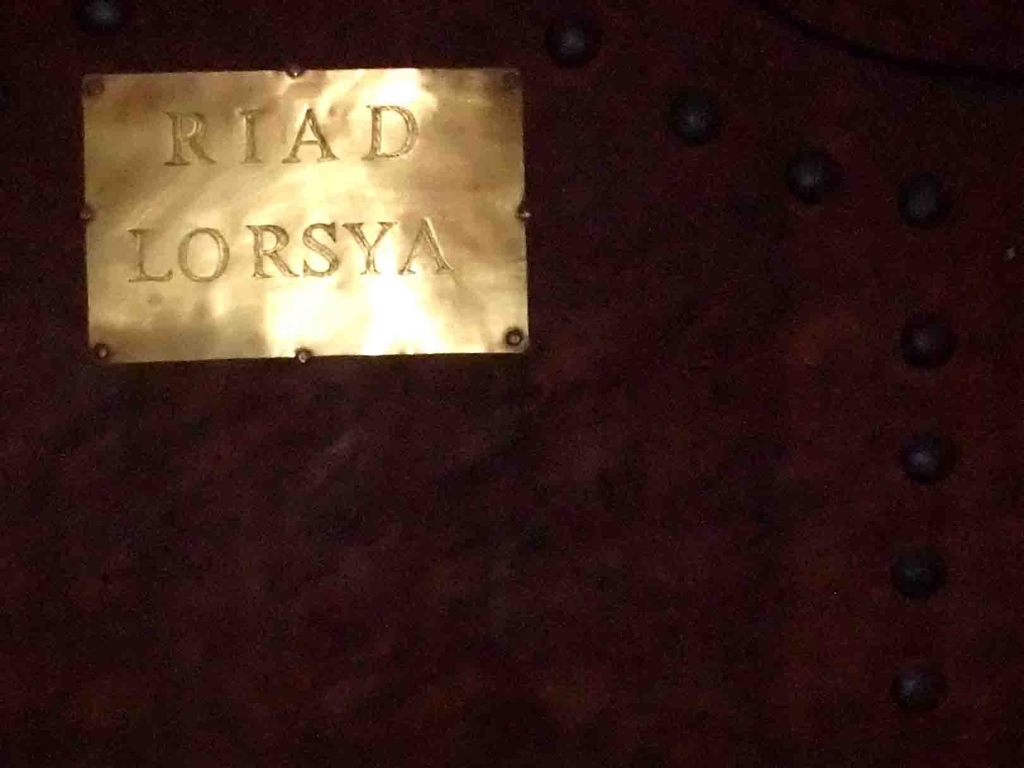What does the style of the signboard and its surroundings tell us? The signboard's brass or gold-colored metal against a dark wooden background with decorative studs suggests a traditional and elegant design, which is often seen in classic or historic establishments. The choice of materials and the artisanal crafting of the signboard reflect a commitment to aesthetics and could signify that 'RIAD LORSYA' prides itself on providing a luxurious and culturally rich environment. 